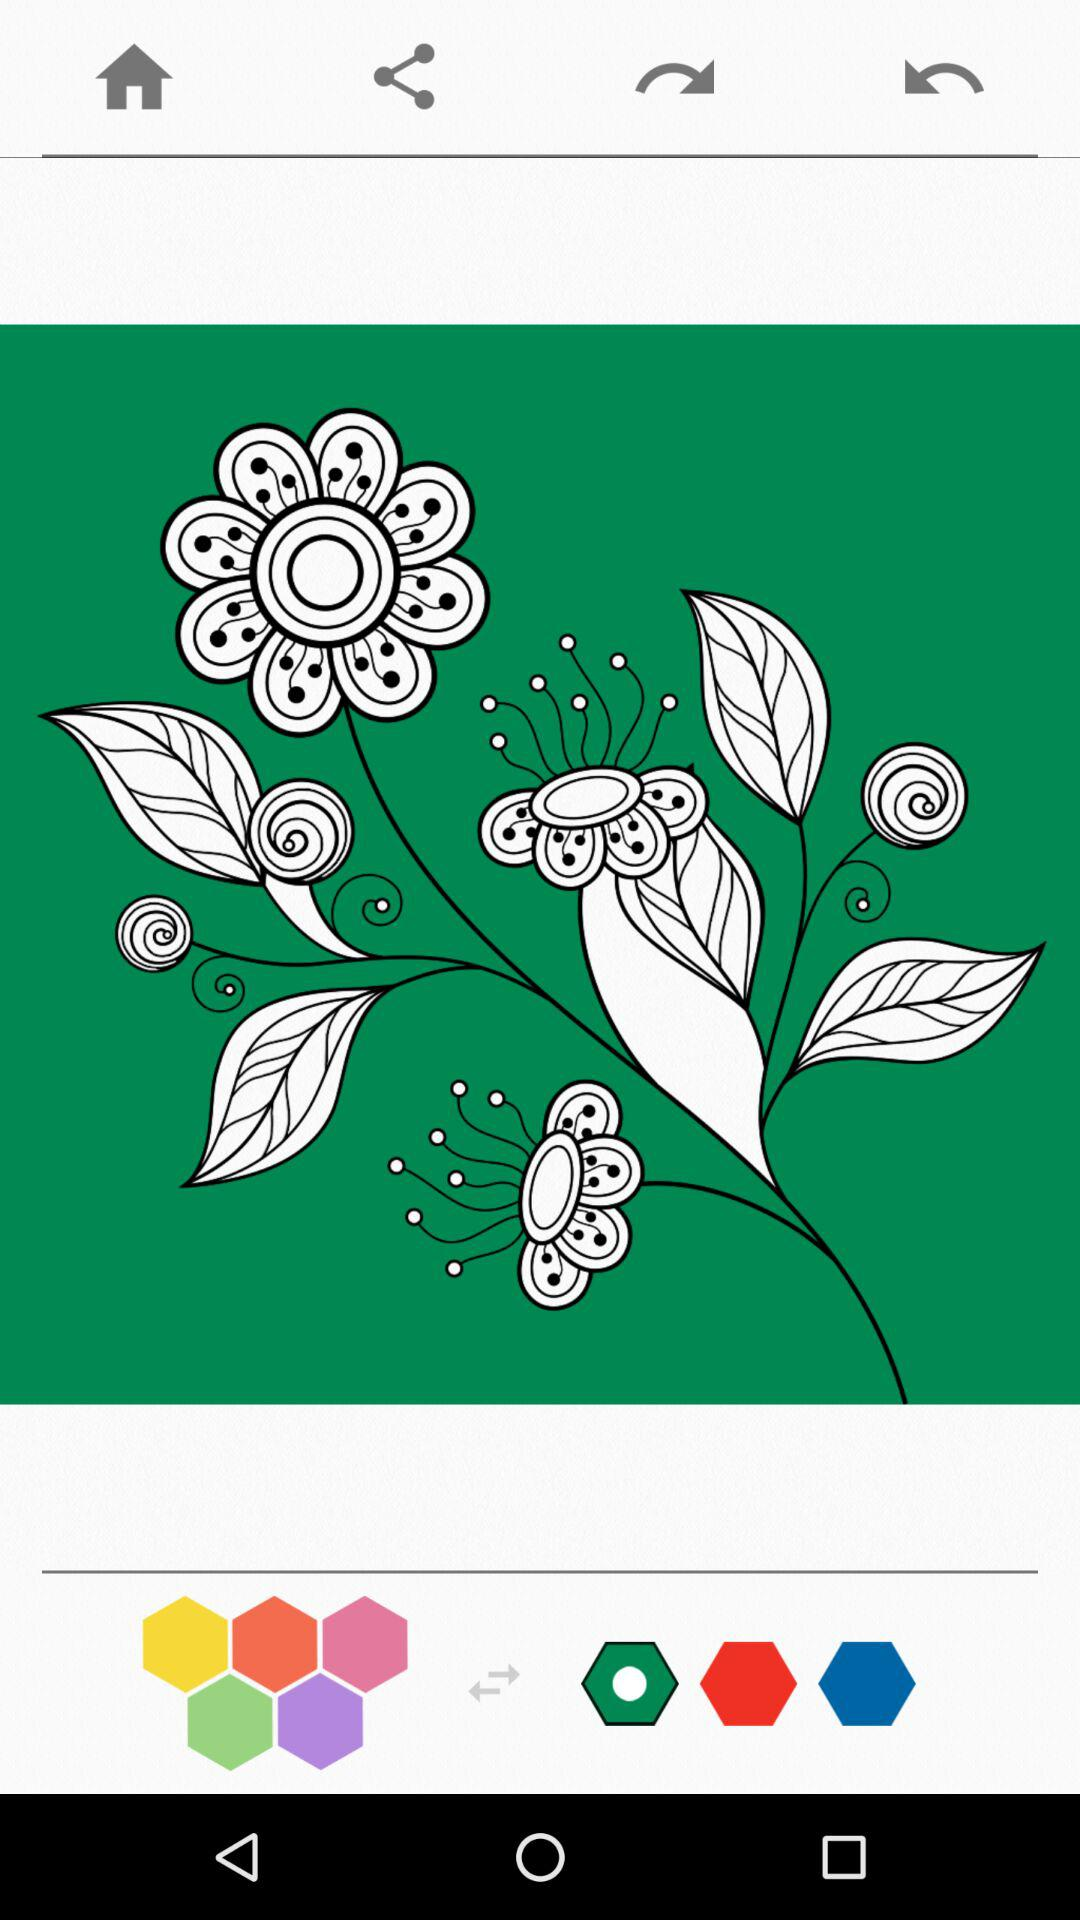How many hexagons have a white circle in the middle?
Answer the question using a single word or phrase. 1 